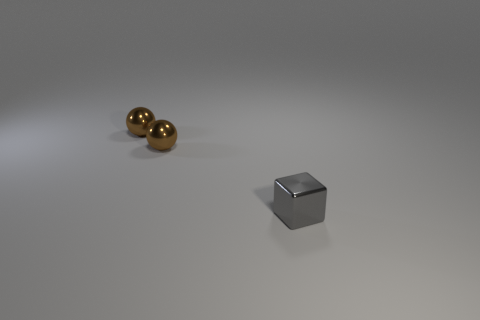Add 1 spheres. How many objects exist? 4 Subtract 1 spheres. How many spheres are left? 1 Subtract all balls. How many objects are left? 1 Subtract all yellow cubes. Subtract all gray cylinders. How many cubes are left? 1 Subtract all small metallic things. Subtract all small brown rubber spheres. How many objects are left? 0 Add 3 metallic cubes. How many metallic cubes are left? 4 Add 1 tiny brown spheres. How many tiny brown spheres exist? 3 Subtract 0 green cylinders. How many objects are left? 3 